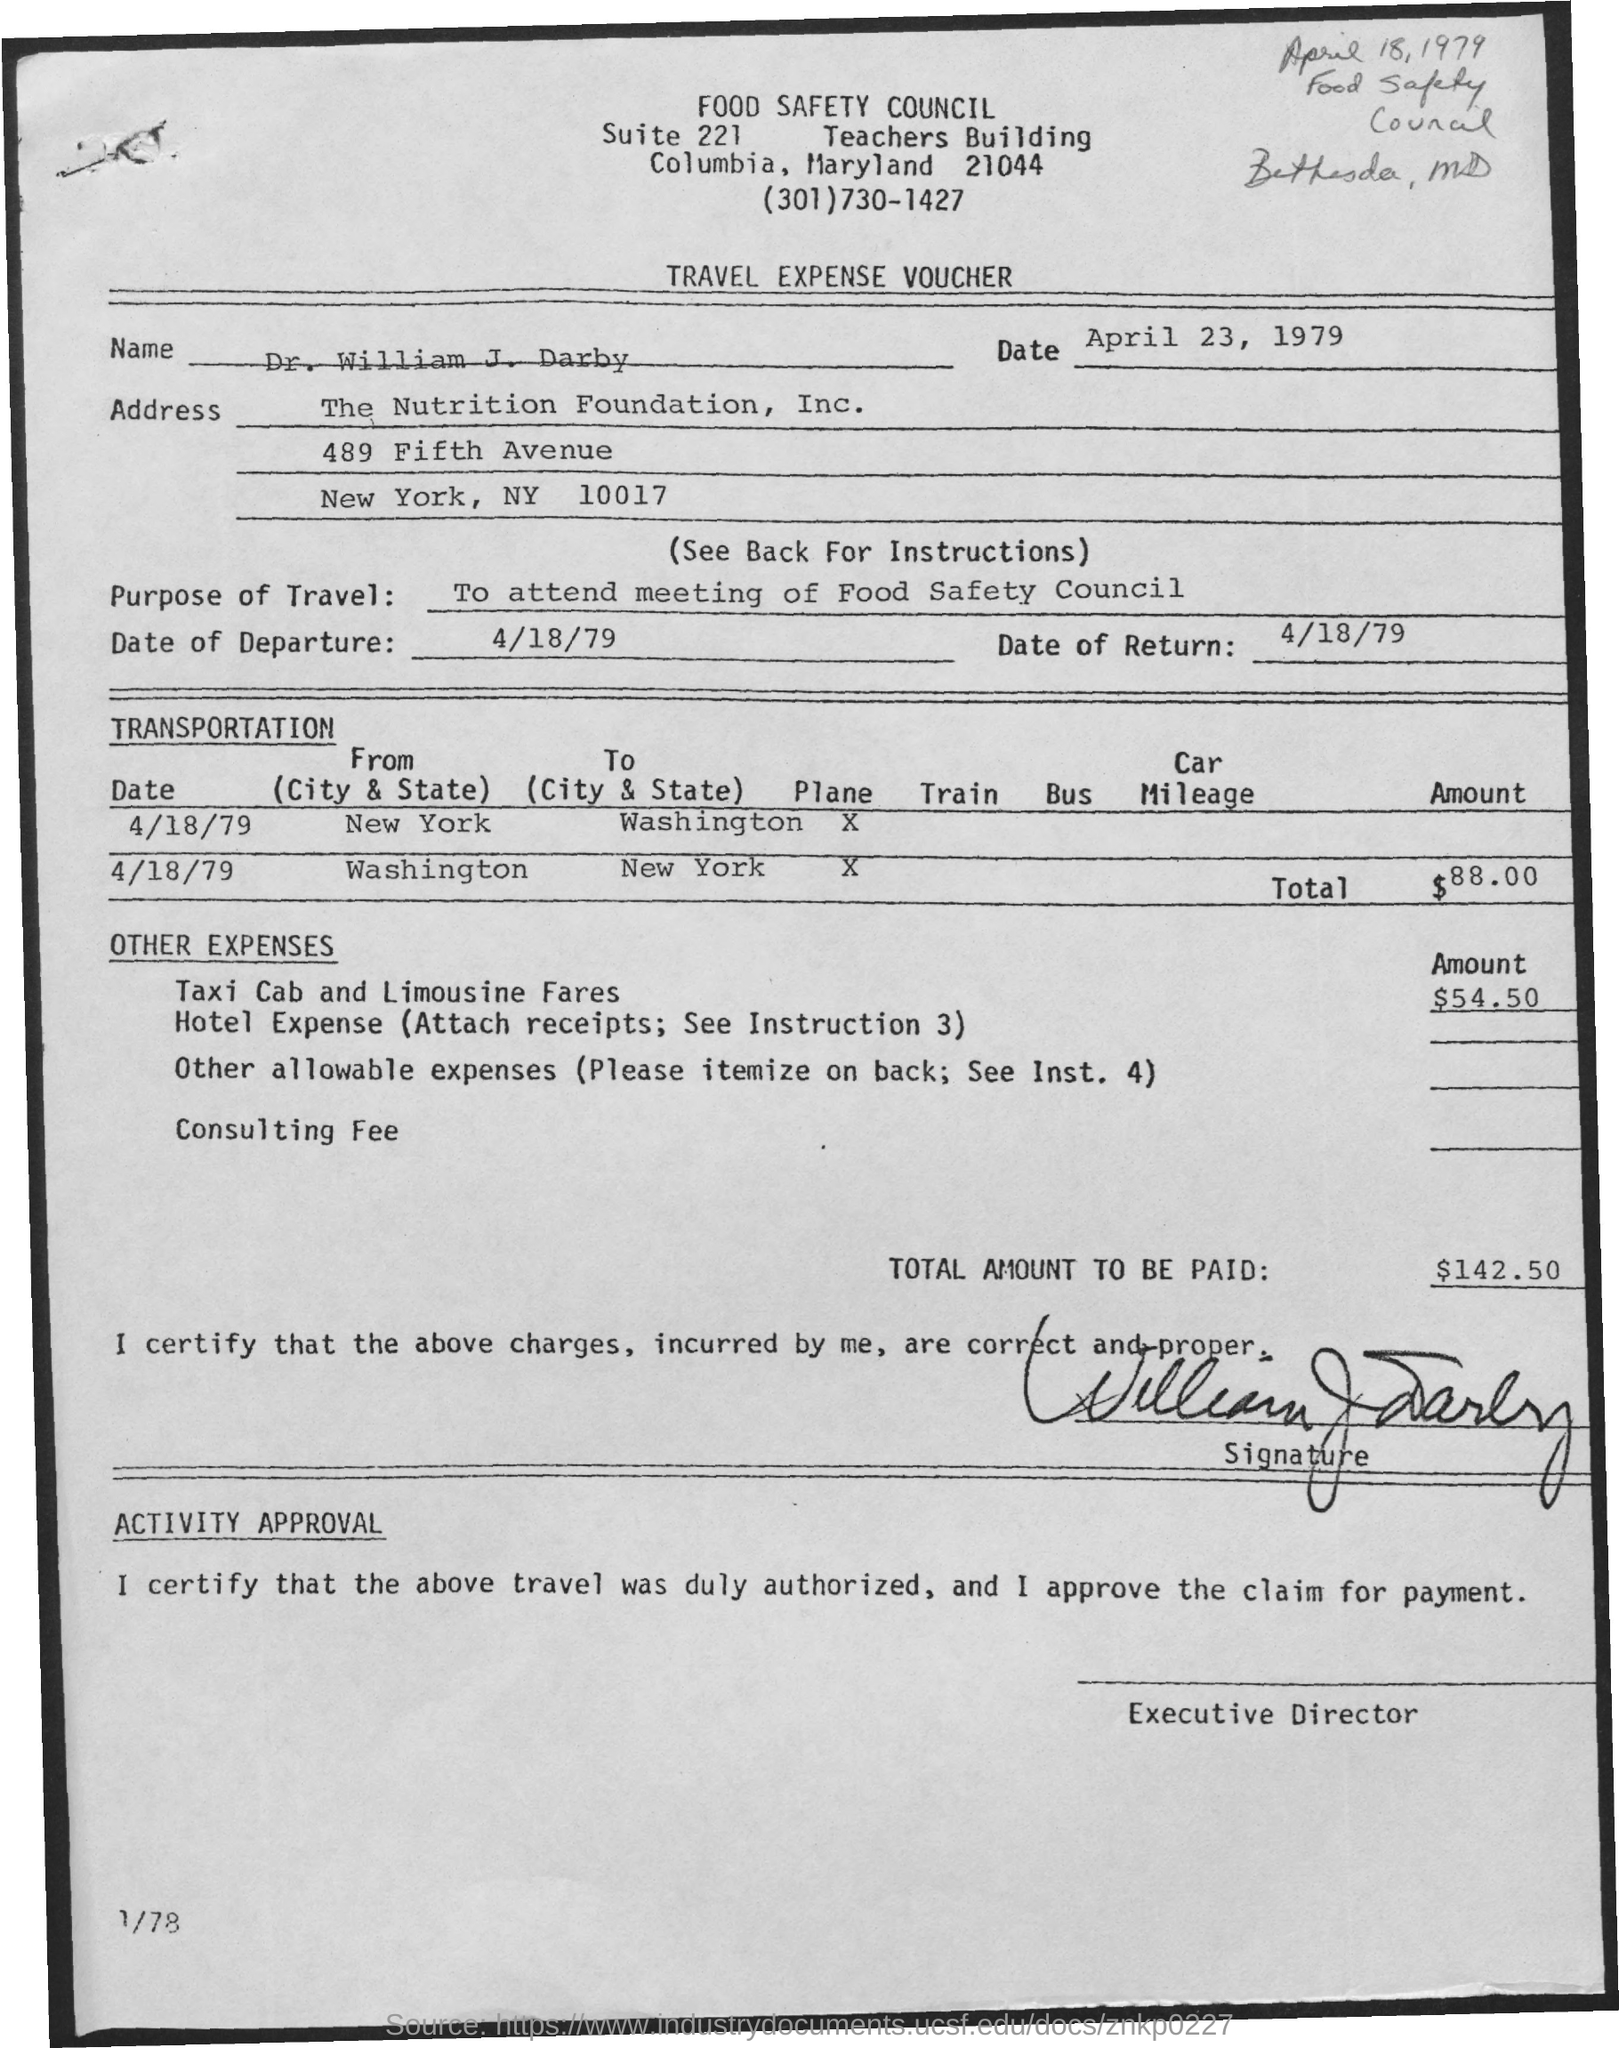Identify some key points in this picture. On April 18, 1979, the date of return, was recorded. Dr. William J. Darby is the name. The date of departure is April 18, 1979. The purpose of travel is to attend meetings of the Food Safety Council in order to ensure the safety of food for consumers. The total amount to be paid is 142.50. 